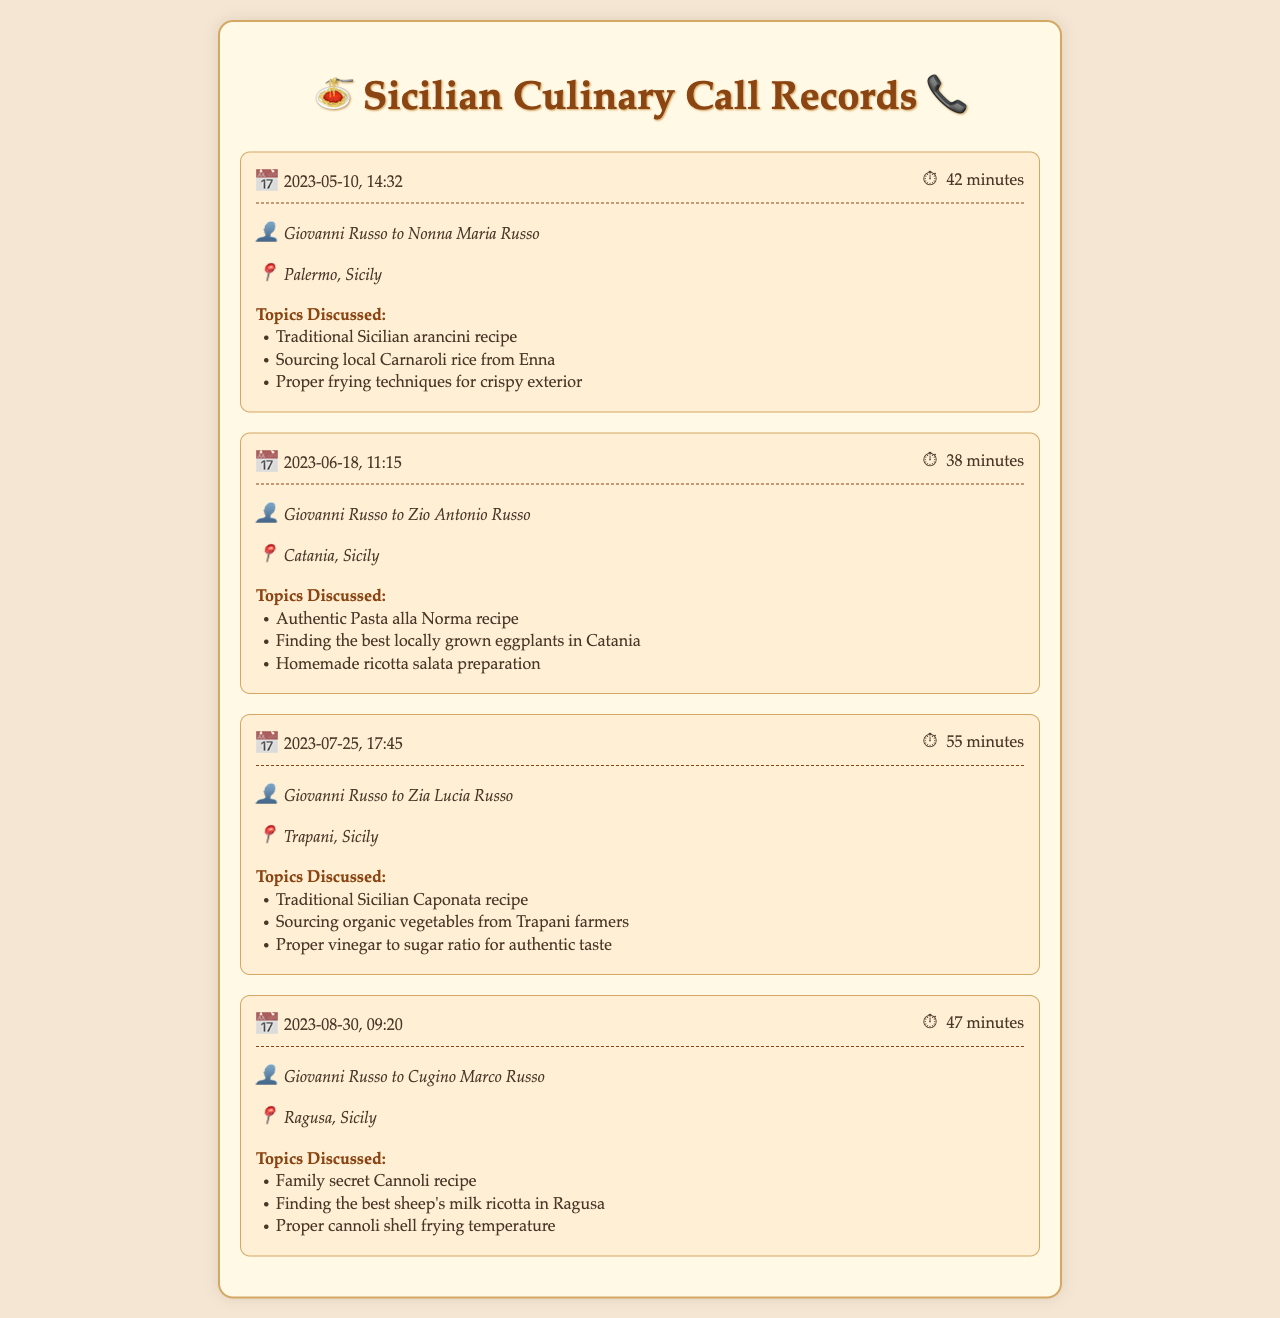What was the date of the first call? The first call was made on 2023-05-10, as shown in the document.
Answer: 2023-05-10 How long was the call with Nonna Maria Russo? The call duration with Nonna Maria Russo was 42 minutes.
Answer: 42 minutes Which recipe did Giovanni discuss with Zio Antonio Russo? The topics included the authentic Pasta alla Norma recipe during the call with Zio Antonio Russo.
Answer: Authentic Pasta alla Norma What is a key ingredient mentioned in the call with Zia Lucia Russo? The call discussed sourcing organic vegetables from Trapani farmers, which is a key ingredient for Caponata.
Answer: Organic vegetables How many calls were made in total? The document lists a total of four calls made between Giovanni and his family members.
Answer: Four Which family member did Giovanni speak to on August 30th? The family member he spoke to on that date was Cugino Marco Russo.
Answer: Cugino Marco Russo What is the main focus of the conversation with Cugino Marco? The main focus of the conversation was about the family secret Cannoli recipe.
Answer: Cannoli recipe What were the proper frying techniques discussed in the first call? The discussion included proper frying techniques for achieving a crispy exterior in arancini.
Answer: Crispy exterior 